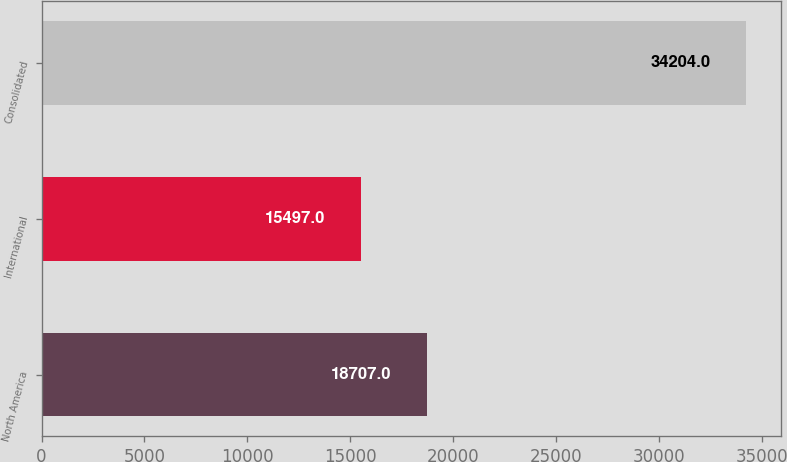Convert chart. <chart><loc_0><loc_0><loc_500><loc_500><bar_chart><fcel>North America<fcel>International<fcel>Consolidated<nl><fcel>18707<fcel>15497<fcel>34204<nl></chart> 